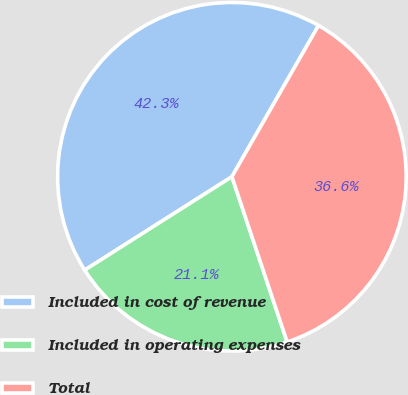<chart> <loc_0><loc_0><loc_500><loc_500><pie_chart><fcel>Included in cost of revenue<fcel>Included in operating expenses<fcel>Total<nl><fcel>42.28%<fcel>21.14%<fcel>36.59%<nl></chart> 